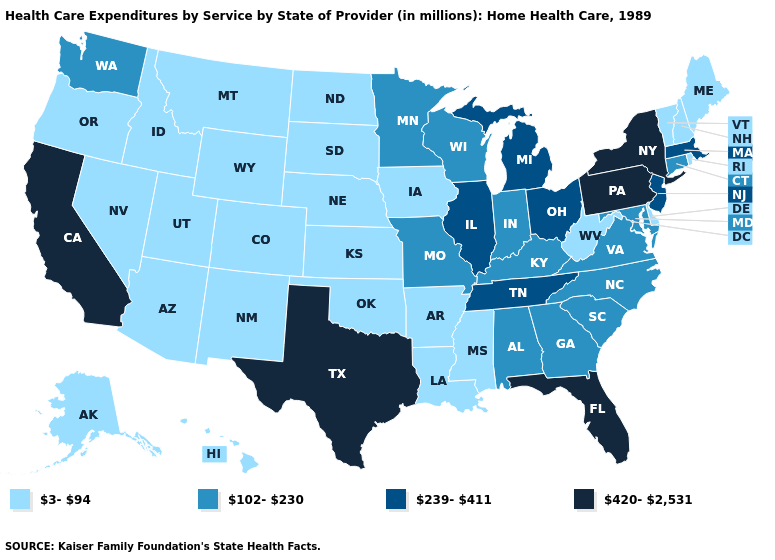Does the first symbol in the legend represent the smallest category?
Answer briefly. Yes. Name the states that have a value in the range 239-411?
Be succinct. Illinois, Massachusetts, Michigan, New Jersey, Ohio, Tennessee. Name the states that have a value in the range 420-2,531?
Answer briefly. California, Florida, New York, Pennsylvania, Texas. Which states have the lowest value in the USA?
Be succinct. Alaska, Arizona, Arkansas, Colorado, Delaware, Hawaii, Idaho, Iowa, Kansas, Louisiana, Maine, Mississippi, Montana, Nebraska, Nevada, New Hampshire, New Mexico, North Dakota, Oklahoma, Oregon, Rhode Island, South Dakota, Utah, Vermont, West Virginia, Wyoming. Does Kansas have the highest value in the USA?
Concise answer only. No. Does Nebraska have the highest value in the USA?
Concise answer only. No. Is the legend a continuous bar?
Answer briefly. No. Name the states that have a value in the range 102-230?
Quick response, please. Alabama, Connecticut, Georgia, Indiana, Kentucky, Maryland, Minnesota, Missouri, North Carolina, South Carolina, Virginia, Washington, Wisconsin. What is the value of Nebraska?
Be succinct. 3-94. Does North Dakota have a lower value than Hawaii?
Keep it brief. No. Which states have the lowest value in the West?
Give a very brief answer. Alaska, Arizona, Colorado, Hawaii, Idaho, Montana, Nevada, New Mexico, Oregon, Utah, Wyoming. Which states have the highest value in the USA?
Give a very brief answer. California, Florida, New York, Pennsylvania, Texas. What is the value of Pennsylvania?
Be succinct. 420-2,531. Name the states that have a value in the range 3-94?
Quick response, please. Alaska, Arizona, Arkansas, Colorado, Delaware, Hawaii, Idaho, Iowa, Kansas, Louisiana, Maine, Mississippi, Montana, Nebraska, Nevada, New Hampshire, New Mexico, North Dakota, Oklahoma, Oregon, Rhode Island, South Dakota, Utah, Vermont, West Virginia, Wyoming. 